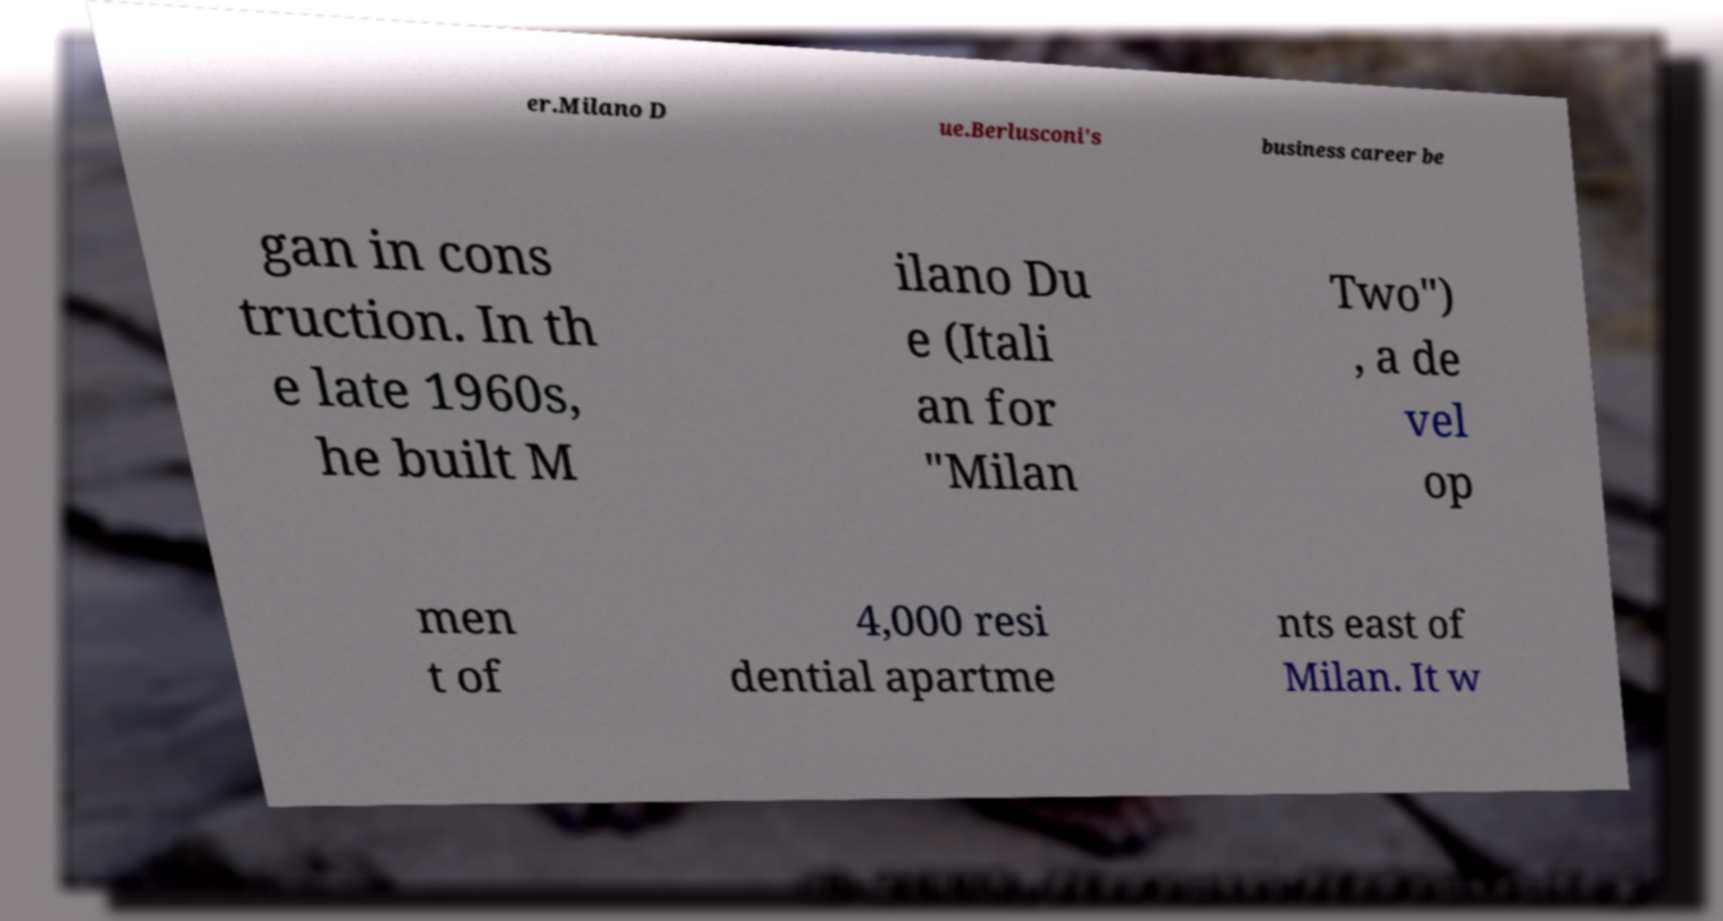Can you accurately transcribe the text from the provided image for me? er.Milano D ue.Berlusconi's business career be gan in cons truction. In th e late 1960s, he built M ilano Du e (Itali an for "Milan Two") , a de vel op men t of 4,000 resi dential apartme nts east of Milan. It w 